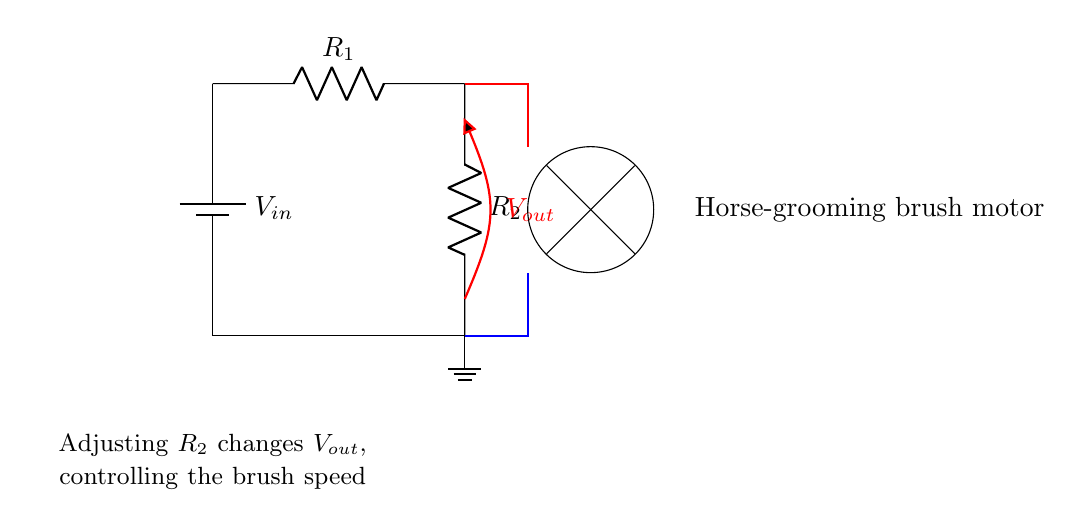What is the purpose of the resistors in this circuit? The resistors R1 and R2 form a voltage divider, which divides the input voltage into a lower output voltage that controls the speed of the motor.
Answer: Voltage divider How many resistors are present in the circuit? There are two resistors shown in the circuit: R1 and R2.
Answer: Two What does adjusting R2 do in this circuit? Adjusting R2 changes the output voltage (Vout), which in turn controls the speed of the horse-grooming brush motor, making it faster or slower.
Answer: Controls brush speed What is the symbol for the power supply in this circuit? The symbol for the power supply is a battery, which is shown at the left side of the circuit diagram.
Answer: Battery What is the output voltage labeled as in the circuit? The output voltage is labeled as Vout, which is represented in red on the circuit diagram.
Answer: Vout What will happen to Vout if R1 is increased? If R1 is increased, Vout will decrease because a larger R1 will result in less voltage across R2, decreasing the output voltage further.
Answer: Decrease Which component directly connects to the horse-grooming brush motor? The motor is connected to the output voltage Vout, which powers the motor based on the voltage divider configuration.
Answer: Vout 